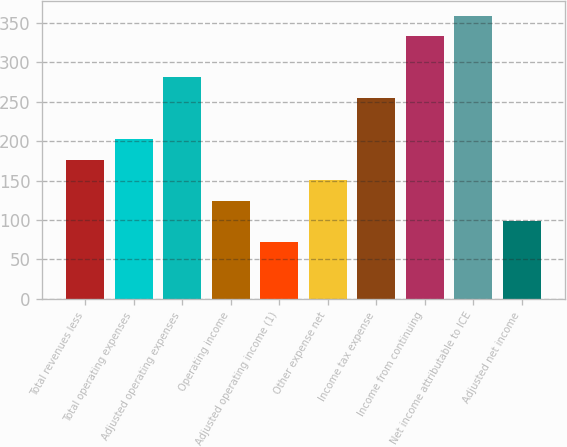Convert chart. <chart><loc_0><loc_0><loc_500><loc_500><bar_chart><fcel>Total revenues less<fcel>Total operating expenses<fcel>Adjusted operating expenses<fcel>Operating income<fcel>Adjusted operating income (1)<fcel>Other expense net<fcel>Income tax expense<fcel>Income from continuing<fcel>Net income attributable to ICE<fcel>Adjusted net income<nl><fcel>176.4<fcel>202.5<fcel>280.8<fcel>124.2<fcel>72<fcel>150.3<fcel>254.7<fcel>333<fcel>359.1<fcel>98.1<nl></chart> 